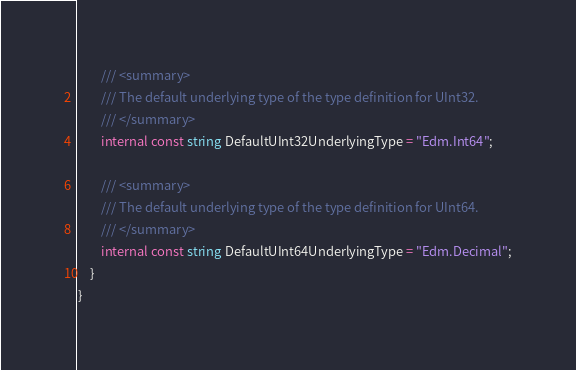Convert code to text. <code><loc_0><loc_0><loc_500><loc_500><_C#_>        /// <summary>
        /// The default underlying type of the type definition for UInt32.
        /// </summary>
        internal const string DefaultUInt32UnderlyingType = "Edm.Int64";

        /// <summary>
        /// The default underlying type of the type definition for UInt64.
        /// </summary>
        internal const string DefaultUInt64UnderlyingType = "Edm.Decimal";
    }
}
</code> 